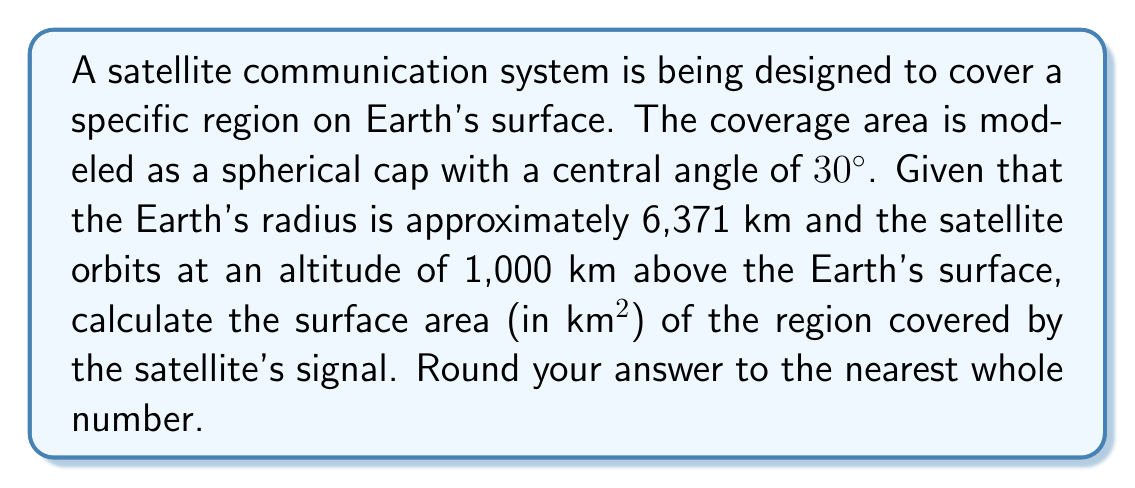Teach me how to tackle this problem. Let's approach this step-by-step:

1) First, we need to calculate the radius of the sphere on which the satellite orbits:
   $R = 6371 \text{ km} + 1000 \text{ km} = 7371 \text{ km}$

2) The formula for the surface area of a spherical cap is:
   $A = 2\pi R^2(1-\cos\theta)$
   where $R$ is the radius and $\theta$ is half the central angle.

3) Our central angle is $30°$, so $\theta = 15°$

4) We need to convert $15°$ to radians:
   $15° \times \frac{\pi}{180°} = 0.2618 \text{ radians}$

5) Now we can plug everything into our formula:
   $$\begin{align}
   A &= 2\pi (7371)^2(1-\cos(0.2618)) \\
   &= 2\pi \times 54331641 \times (1-0.9659) \\
   &= 341551017.8 \times 0.0341 \\
   &= 11646890.7 \text{ km}^2
   \end{align}$$

6) Rounding to the nearest whole number:
   $11646891 \text{ km}^2$

This calculation uses spherical geometry to determine the coverage area, which is crucial for optimizing satellite communication systems. It's particularly relevant to EU-funded research in computer science, as it combines mathematical modeling with practical applications in telecommunications.
Answer: 11646891 km² 